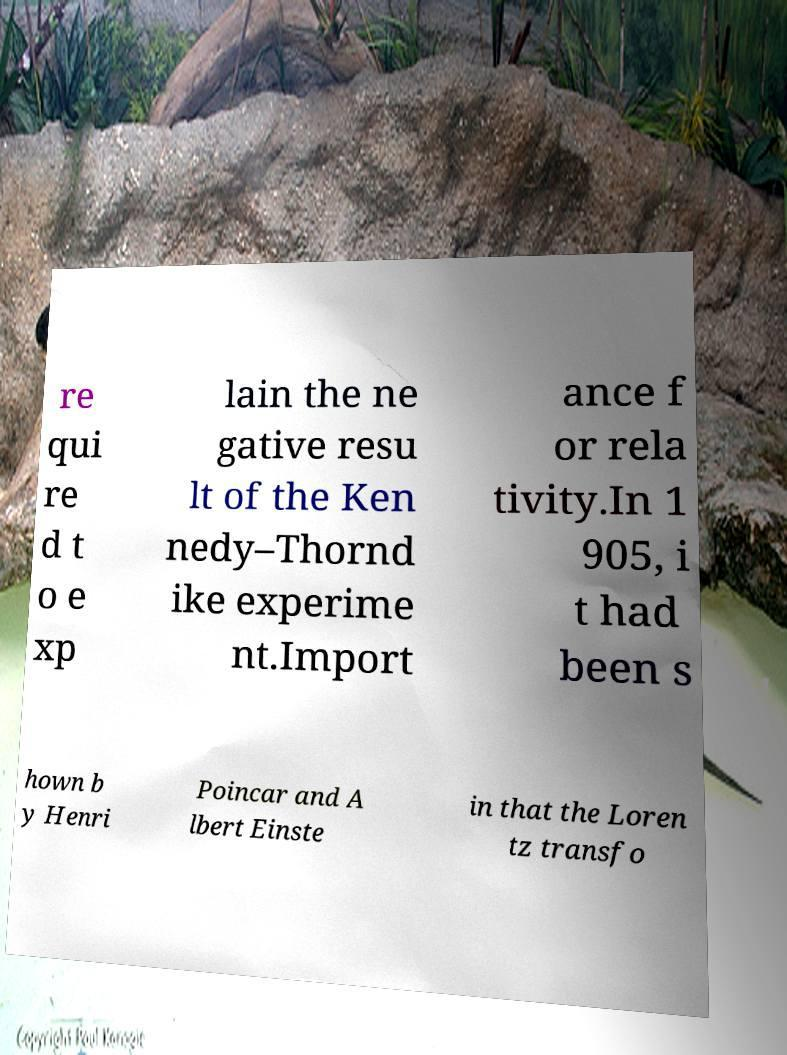Could you assist in decoding the text presented in this image and type it out clearly? re qui re d t o e xp lain the ne gative resu lt of the Ken nedy–Thornd ike experime nt.Import ance f or rela tivity.In 1 905, i t had been s hown b y Henri Poincar and A lbert Einste in that the Loren tz transfo 